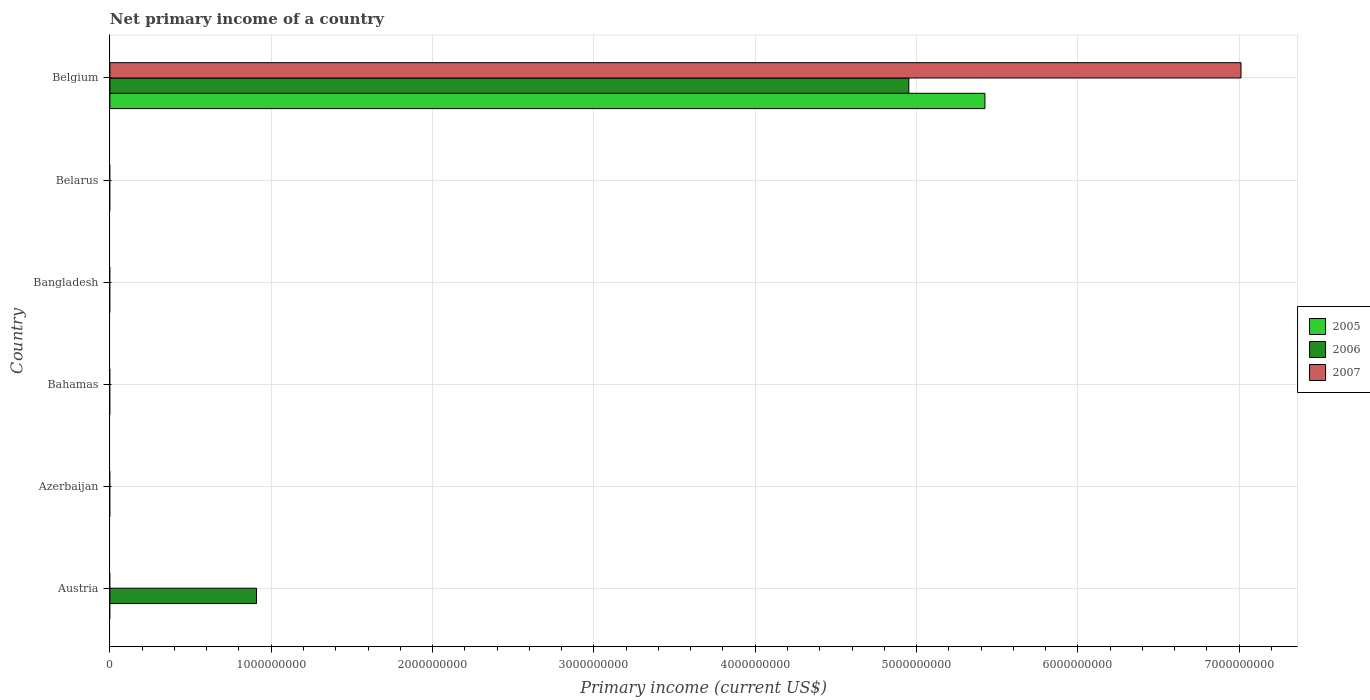Are the number of bars on each tick of the Y-axis equal?
Your answer should be very brief. No. What is the label of the 4th group of bars from the top?
Your answer should be very brief. Bahamas. In how many cases, is the number of bars for a given country not equal to the number of legend labels?
Offer a very short reply. 5. What is the primary income in 2006 in Austria?
Provide a succinct answer. 9.09e+08. Across all countries, what is the maximum primary income in 2006?
Offer a terse response. 4.95e+09. Across all countries, what is the minimum primary income in 2006?
Your response must be concise. 0. What is the total primary income in 2006 in the graph?
Provide a succinct answer. 5.86e+09. What is the difference between the primary income in 2005 in Bangladesh and the primary income in 2006 in Belgium?
Offer a very short reply. -4.95e+09. What is the average primary income in 2006 per country?
Offer a very short reply. 9.77e+08. What is the difference between the primary income in 2006 and primary income in 2005 in Belgium?
Give a very brief answer. -4.72e+08. What is the difference between the highest and the lowest primary income in 2005?
Give a very brief answer. 5.42e+09. In how many countries, is the primary income in 2007 greater than the average primary income in 2007 taken over all countries?
Offer a very short reply. 1. What is the difference between two consecutive major ticks on the X-axis?
Ensure brevity in your answer.  1.00e+09. Does the graph contain any zero values?
Your response must be concise. Yes. What is the title of the graph?
Your answer should be very brief. Net primary income of a country. Does "1960" appear as one of the legend labels in the graph?
Keep it short and to the point. No. What is the label or title of the X-axis?
Provide a succinct answer. Primary income (current US$). What is the label or title of the Y-axis?
Give a very brief answer. Country. What is the Primary income (current US$) in 2005 in Austria?
Offer a very short reply. 0. What is the Primary income (current US$) in 2006 in Austria?
Offer a very short reply. 9.09e+08. What is the Primary income (current US$) of 2007 in Austria?
Your response must be concise. 0. What is the Primary income (current US$) of 2005 in Azerbaijan?
Ensure brevity in your answer.  0. What is the Primary income (current US$) of 2006 in Azerbaijan?
Your answer should be very brief. 0. What is the Primary income (current US$) in 2007 in Azerbaijan?
Ensure brevity in your answer.  0. What is the Primary income (current US$) of 2006 in Bahamas?
Your answer should be very brief. 0. What is the Primary income (current US$) in 2005 in Bangladesh?
Offer a terse response. 0. What is the Primary income (current US$) of 2007 in Bangladesh?
Make the answer very short. 0. What is the Primary income (current US$) in 2005 in Belgium?
Keep it short and to the point. 5.42e+09. What is the Primary income (current US$) of 2006 in Belgium?
Keep it short and to the point. 4.95e+09. What is the Primary income (current US$) of 2007 in Belgium?
Offer a terse response. 7.01e+09. Across all countries, what is the maximum Primary income (current US$) in 2005?
Your answer should be compact. 5.42e+09. Across all countries, what is the maximum Primary income (current US$) in 2006?
Your answer should be compact. 4.95e+09. Across all countries, what is the maximum Primary income (current US$) in 2007?
Your answer should be compact. 7.01e+09. Across all countries, what is the minimum Primary income (current US$) of 2005?
Keep it short and to the point. 0. Across all countries, what is the minimum Primary income (current US$) in 2006?
Give a very brief answer. 0. Across all countries, what is the minimum Primary income (current US$) in 2007?
Your response must be concise. 0. What is the total Primary income (current US$) in 2005 in the graph?
Provide a short and direct response. 5.42e+09. What is the total Primary income (current US$) of 2006 in the graph?
Offer a terse response. 5.86e+09. What is the total Primary income (current US$) in 2007 in the graph?
Give a very brief answer. 7.01e+09. What is the difference between the Primary income (current US$) in 2006 in Austria and that in Belgium?
Keep it short and to the point. -4.04e+09. What is the difference between the Primary income (current US$) in 2006 in Austria and the Primary income (current US$) in 2007 in Belgium?
Provide a short and direct response. -6.10e+09. What is the average Primary income (current US$) of 2005 per country?
Your answer should be very brief. 9.04e+08. What is the average Primary income (current US$) of 2006 per country?
Provide a short and direct response. 9.77e+08. What is the average Primary income (current US$) in 2007 per country?
Your answer should be compact. 1.17e+09. What is the difference between the Primary income (current US$) in 2005 and Primary income (current US$) in 2006 in Belgium?
Provide a short and direct response. 4.72e+08. What is the difference between the Primary income (current US$) of 2005 and Primary income (current US$) of 2007 in Belgium?
Keep it short and to the point. -1.59e+09. What is the difference between the Primary income (current US$) of 2006 and Primary income (current US$) of 2007 in Belgium?
Your response must be concise. -2.06e+09. What is the ratio of the Primary income (current US$) of 2006 in Austria to that in Belgium?
Give a very brief answer. 0.18. What is the difference between the highest and the lowest Primary income (current US$) in 2005?
Offer a terse response. 5.42e+09. What is the difference between the highest and the lowest Primary income (current US$) in 2006?
Provide a short and direct response. 4.95e+09. What is the difference between the highest and the lowest Primary income (current US$) in 2007?
Keep it short and to the point. 7.01e+09. 